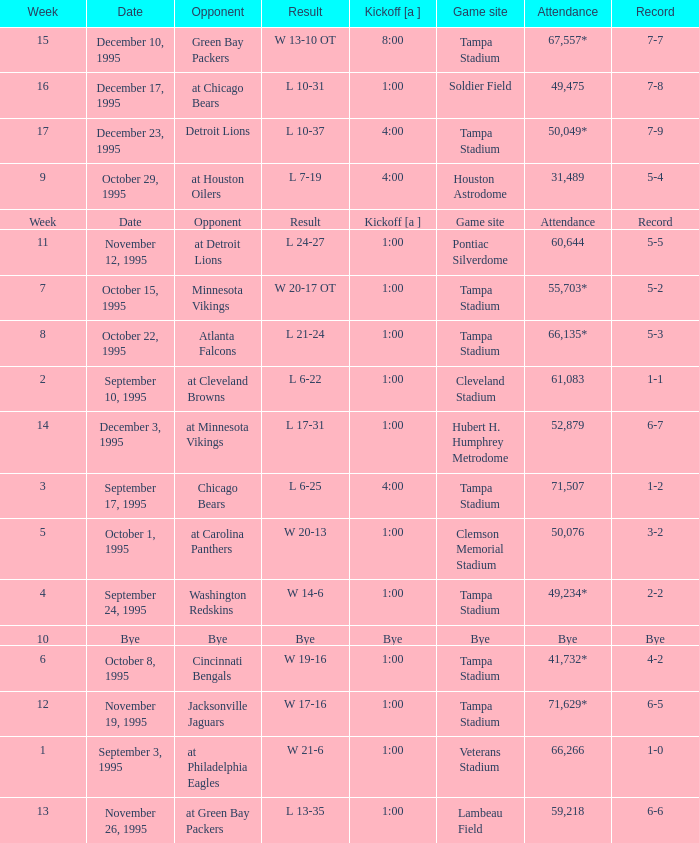Who did the Tampa Bay Buccaneers play on december 23, 1995? Detroit Lions. 